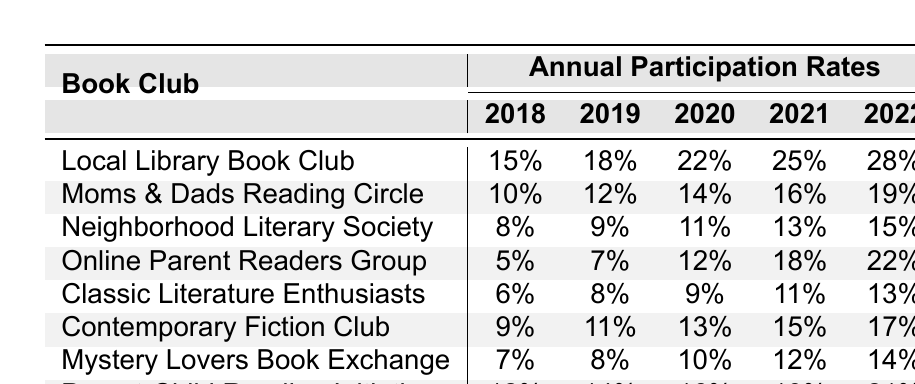What was the participation rate of the "Online Parent Readers Group" in 2020? The table shows the participation rates for each book club in 2020. The rate for the "Online Parent Readers Group" in that year is clearly listed as 12%.
Answer: 12% Which book club had the highest participation rate in 2022? Looking at the participation rates for 2022, "Local Library Book Club" has the highest rate at 28%.
Answer: Local Library Book Club What was the average participation rate of the "Moms & Dads Reading Circle" over all years? The participation rates for the "Moms & Dads Reading Circle" are 10%, 12%, 14%, 16%, and 19%. Summing these gives 71%. Dividing by 5 results in an average of 71% / 5 = 14.2%.
Answer: 14.2% Did the "Neighborhood Literary Society" see an increase in participation rates from 2018 to 2022? By comparing the 2018 rate of 8% to the 2022 rate of 15%, it is evident that the rate increased over the years.
Answer: Yes What is the difference in participation rates between the "Mystery Lovers Book Exchange" in 2019 and 2021? The participation rates for "Mystery Lovers Book Exchange" are 8% in 2019 and 12% in 2021. The difference is 12% - 8% = 4%.
Answer: 4% Which book club shows the most consistent increase in participation rates from year to year? Analyzing the table, "Local Library Book Club" has steady increases each year: 15% to 18% to 22% to 25% to 28%. All increases are consistent.
Answer: Local Library Book Club What was the overall trend in participation rates from 2018 to 2022 for the "Classic Literature Enthusiasts"? The participation rates for the "Classic Literature Enthusiasts" progressed as follows: 6% (2018), 8% (2019), 9% (2020), 11% (2021), and 13% (2022), indicating a clear upward trend.
Answer: Upward trend How many book clubs had a participation rate of at least 20% in 2022? In 2022, the rates for "Local Library Book Club" (28%), "Online Parent Readers Group" (22%), and "Parent-Child Reading Initiative" (21%) are all above 20%. That makes three clubs.
Answer: 3 